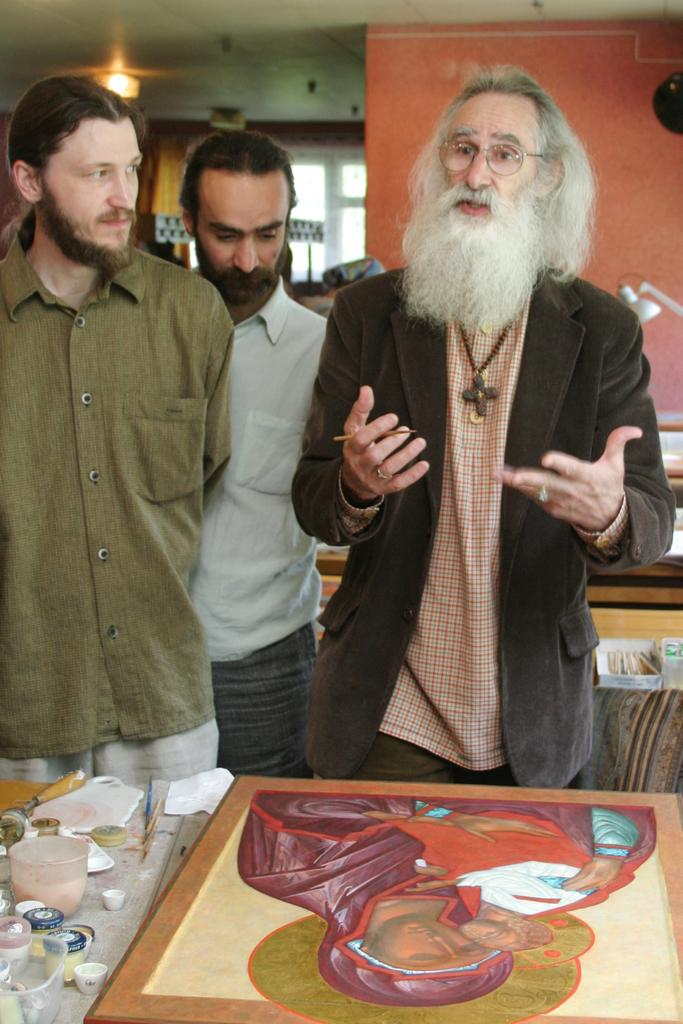What are the people in the image doing? Some people are painting in the image. What objects can be seen on a table in the image? There are objects on a table in the image. What can be seen in the background of the image? There is a lamp, a window, and a ceiling with lights visible in the background of the image. What type of scent is being emitted by the brush in the image? There is no brush present in the image, and therefore no scent can be associated with it. 